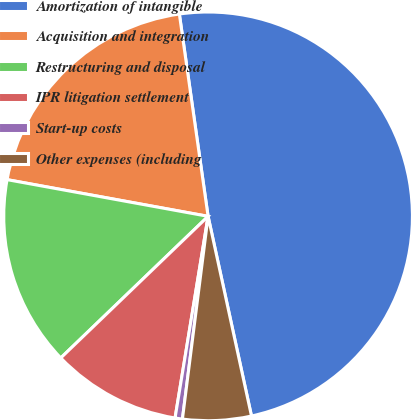Convert chart. <chart><loc_0><loc_0><loc_500><loc_500><pie_chart><fcel>Amortization of intangible<fcel>Acquisition and integration<fcel>Restructuring and disposal<fcel>IPR litigation settlement<fcel>Start-up costs<fcel>Other expenses (including<nl><fcel>48.84%<fcel>19.88%<fcel>15.06%<fcel>10.23%<fcel>0.58%<fcel>5.41%<nl></chart> 